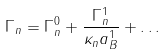Convert formula to latex. <formula><loc_0><loc_0><loc_500><loc_500>\Gamma _ { n } = \Gamma _ { n } ^ { 0 } + \frac { \Gamma _ { n } ^ { 1 } } { \kappa _ { n } a _ { B } ^ { 1 } } + \dots</formula> 